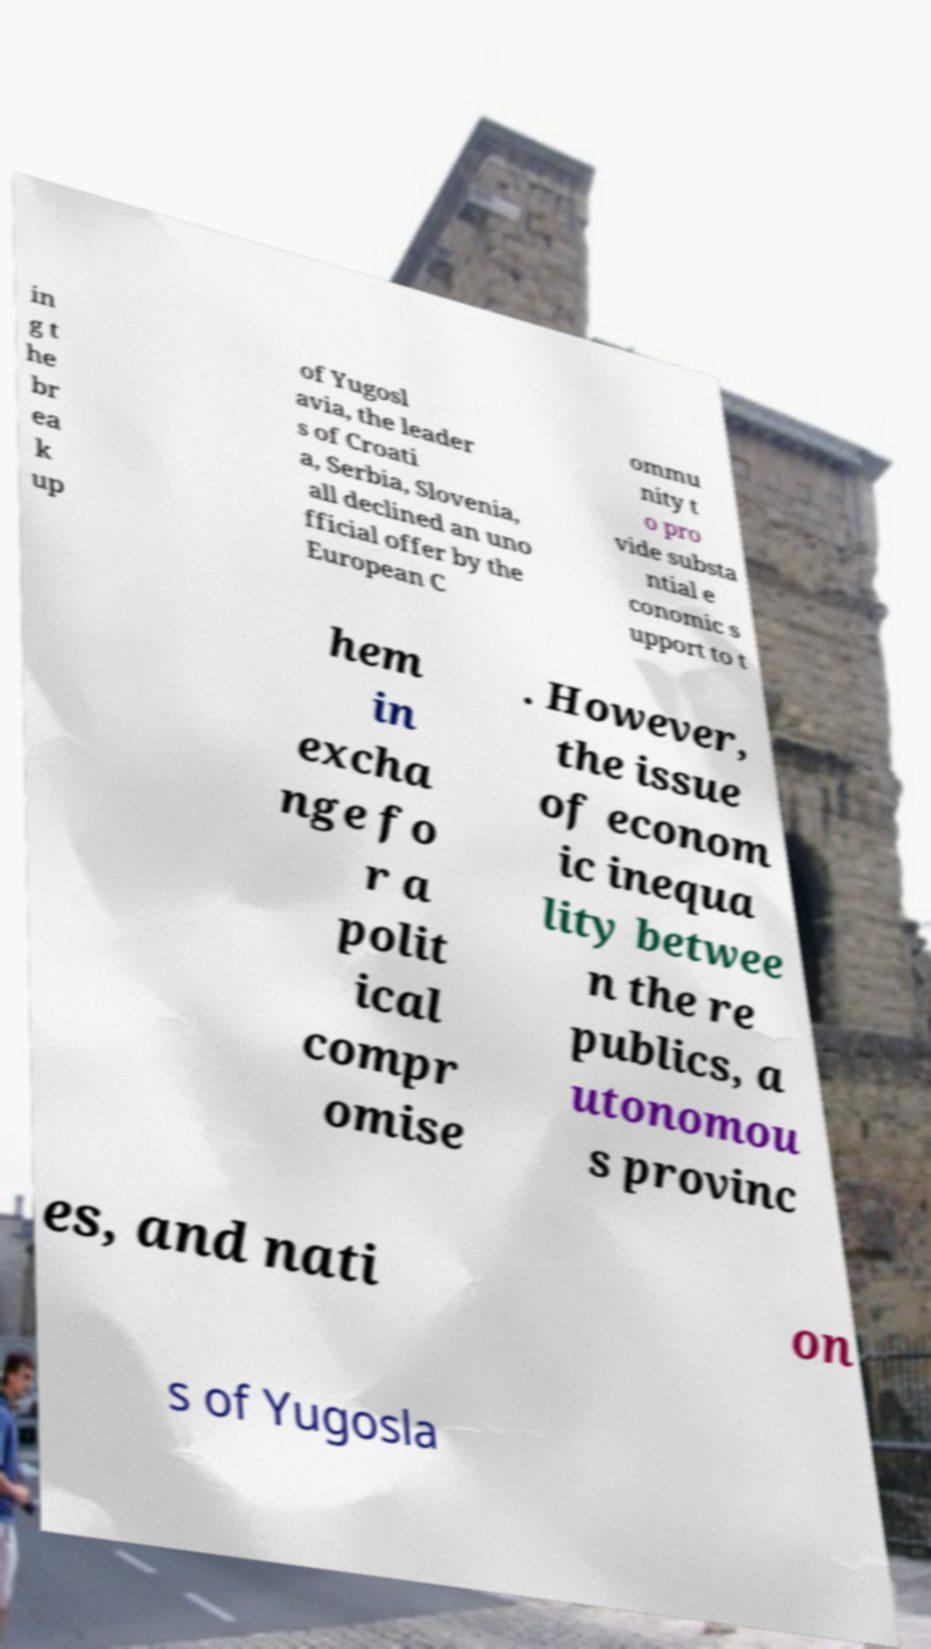There's text embedded in this image that I need extracted. Can you transcribe it verbatim? in g t he br ea k up of Yugosl avia, the leader s of Croati a, Serbia, Slovenia, all declined an uno fficial offer by the European C ommu nity t o pro vide substa ntial e conomic s upport to t hem in excha nge fo r a polit ical compr omise . However, the issue of econom ic inequa lity betwee n the re publics, a utonomou s provinc es, and nati on s of Yugosla 